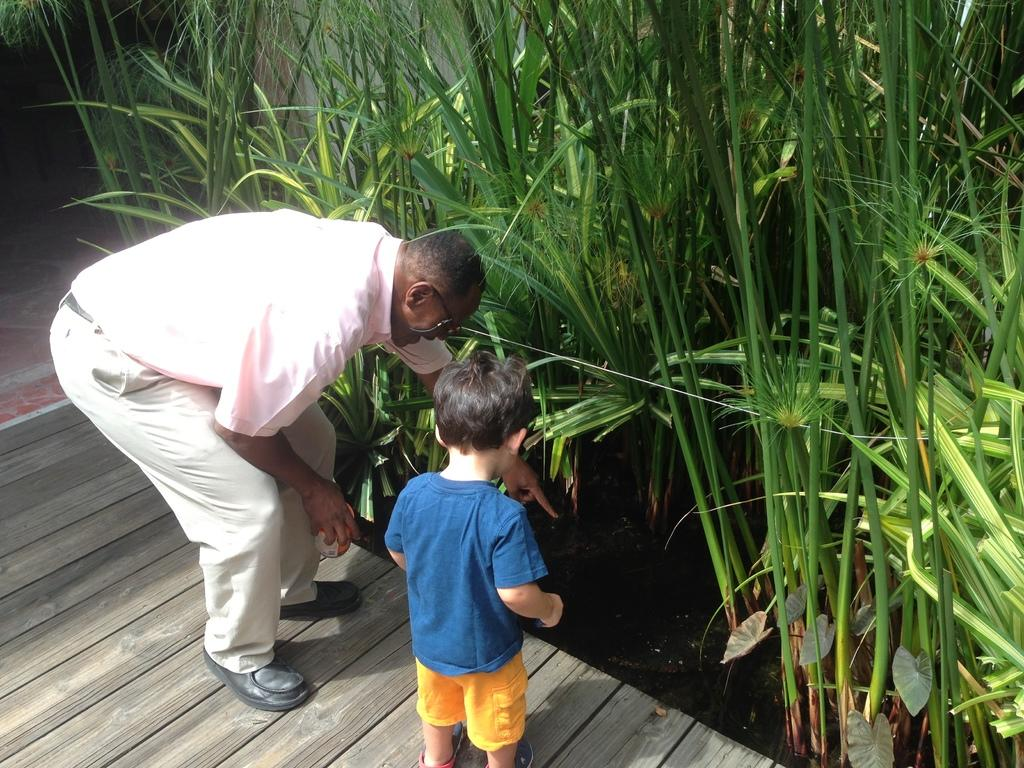Who is present in the image? There is a person in the image, specifically a boy. What can be seen in the background of the image? There are plants in the image. What type of path is visible in the image? There is a walkway in the image. What type of coal is being used to fuel the growth of the plants in the image? There is no coal present in the image, and the plants' growth is not mentioned. 